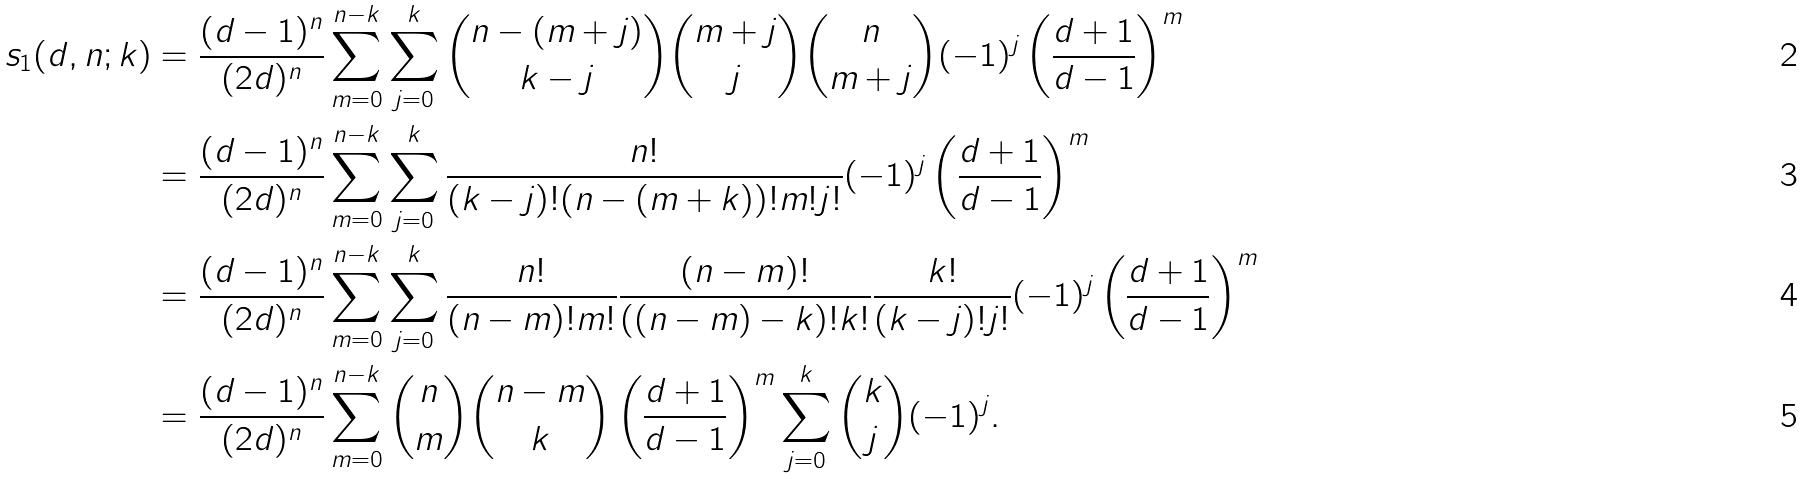Convert formula to latex. <formula><loc_0><loc_0><loc_500><loc_500>s _ { 1 } ( d , n ; k ) & = \frac { ( d - 1 ) ^ { n } } { ( 2 d ) ^ { n } } \sum _ { m = 0 } ^ { n - k } \sum _ { j = 0 } ^ { k } \binom { n - ( m + j ) } { k - j } \binom { m + j } { j } \binom { n } { m + j } ( - 1 ) ^ { j } \left ( \frac { d + 1 } { d - 1 } \right ) ^ { m } \\ & = \frac { ( d - 1 ) ^ { n } } { ( 2 d ) ^ { n } } \sum _ { m = 0 } ^ { n - k } \sum _ { j = 0 } ^ { k } \frac { n ! } { ( k - j ) ! ( n - ( m + k ) ) ! m ! j ! } ( - 1 ) ^ { j } \left ( \frac { d + 1 } { d - 1 } \right ) ^ { m } \\ & = \frac { ( d - 1 ) ^ { n } } { ( 2 d ) ^ { n } } \sum _ { m = 0 } ^ { n - k } \sum _ { j = 0 } ^ { k } \frac { n ! } { ( n - m ) ! m ! } \frac { ( n - m ) ! } { ( ( n - m ) - k ) ! k ! } \frac { k ! } { ( k - j ) ! j ! } ( - 1 ) ^ { j } \left ( \frac { d + 1 } { d - 1 } \right ) ^ { m } \\ & = \frac { ( d - 1 ) ^ { n } } { ( 2 d ) ^ { n } } \sum _ { m = 0 } ^ { n - k } \binom { n } { m } \binom { n - m } { k } \left ( \frac { d + 1 } { d - 1 } \right ) ^ { m } \sum _ { j = 0 } ^ { k } \binom { k } { j } ( - 1 ) ^ { j } .</formula> 